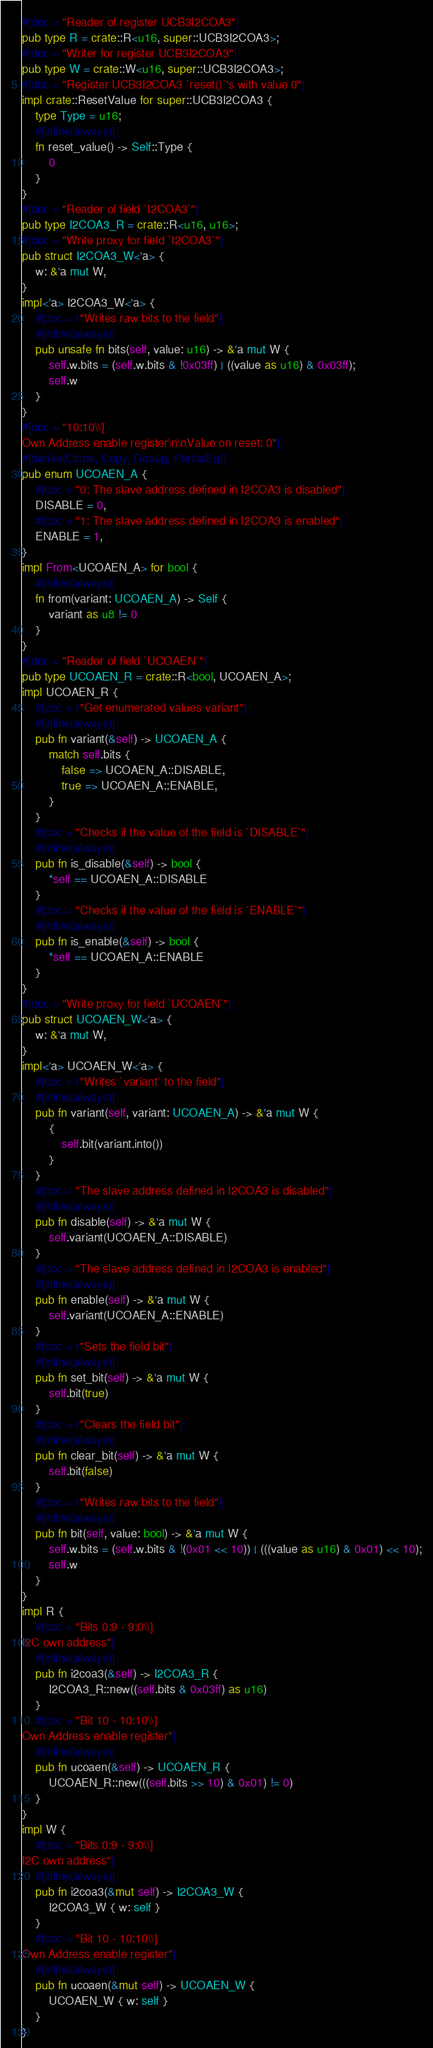Convert code to text. <code><loc_0><loc_0><loc_500><loc_500><_Rust_>#[doc = "Reader of register UCB3I2COA3"]
pub type R = crate::R<u16, super::UCB3I2COA3>;
#[doc = "Writer for register UCB3I2COA3"]
pub type W = crate::W<u16, super::UCB3I2COA3>;
#[doc = "Register UCB3I2COA3 `reset()`'s with value 0"]
impl crate::ResetValue for super::UCB3I2COA3 {
    type Type = u16;
    #[inline(always)]
    fn reset_value() -> Self::Type {
        0
    }
}
#[doc = "Reader of field `I2COA3`"]
pub type I2COA3_R = crate::R<u16, u16>;
#[doc = "Write proxy for field `I2COA3`"]
pub struct I2COA3_W<'a> {
    w: &'a mut W,
}
impl<'a> I2COA3_W<'a> {
    #[doc = r"Writes raw bits to the field"]
    #[inline(always)]
    pub unsafe fn bits(self, value: u16) -> &'a mut W {
        self.w.bits = (self.w.bits & !0x03ff) | ((value as u16) & 0x03ff);
        self.w
    }
}
#[doc = "10:10\\]
Own Address enable register\n\nValue on reset: 0"]
#[derive(Clone, Copy, Debug, PartialEq)]
pub enum UCOAEN_A {
    #[doc = "0: The slave address defined in I2COA3 is disabled"]
    DISABLE = 0,
    #[doc = "1: The slave address defined in I2COA3 is enabled"]
    ENABLE = 1,
}
impl From<UCOAEN_A> for bool {
    #[inline(always)]
    fn from(variant: UCOAEN_A) -> Self {
        variant as u8 != 0
    }
}
#[doc = "Reader of field `UCOAEN`"]
pub type UCOAEN_R = crate::R<bool, UCOAEN_A>;
impl UCOAEN_R {
    #[doc = r"Get enumerated values variant"]
    #[inline(always)]
    pub fn variant(&self) -> UCOAEN_A {
        match self.bits {
            false => UCOAEN_A::DISABLE,
            true => UCOAEN_A::ENABLE,
        }
    }
    #[doc = "Checks if the value of the field is `DISABLE`"]
    #[inline(always)]
    pub fn is_disable(&self) -> bool {
        *self == UCOAEN_A::DISABLE
    }
    #[doc = "Checks if the value of the field is `ENABLE`"]
    #[inline(always)]
    pub fn is_enable(&self) -> bool {
        *self == UCOAEN_A::ENABLE
    }
}
#[doc = "Write proxy for field `UCOAEN`"]
pub struct UCOAEN_W<'a> {
    w: &'a mut W,
}
impl<'a> UCOAEN_W<'a> {
    #[doc = r"Writes `variant` to the field"]
    #[inline(always)]
    pub fn variant(self, variant: UCOAEN_A) -> &'a mut W {
        {
            self.bit(variant.into())
        }
    }
    #[doc = "The slave address defined in I2COA3 is disabled"]
    #[inline(always)]
    pub fn disable(self) -> &'a mut W {
        self.variant(UCOAEN_A::DISABLE)
    }
    #[doc = "The slave address defined in I2COA3 is enabled"]
    #[inline(always)]
    pub fn enable(self) -> &'a mut W {
        self.variant(UCOAEN_A::ENABLE)
    }
    #[doc = r"Sets the field bit"]
    #[inline(always)]
    pub fn set_bit(self) -> &'a mut W {
        self.bit(true)
    }
    #[doc = r"Clears the field bit"]
    #[inline(always)]
    pub fn clear_bit(self) -> &'a mut W {
        self.bit(false)
    }
    #[doc = r"Writes raw bits to the field"]
    #[inline(always)]
    pub fn bit(self, value: bool) -> &'a mut W {
        self.w.bits = (self.w.bits & !(0x01 << 10)) | (((value as u16) & 0x01) << 10);
        self.w
    }
}
impl R {
    #[doc = "Bits 0:9 - 9:0\\]
I2C own address"]
    #[inline(always)]
    pub fn i2coa3(&self) -> I2COA3_R {
        I2COA3_R::new((self.bits & 0x03ff) as u16)
    }
    #[doc = "Bit 10 - 10:10\\]
Own Address enable register"]
    #[inline(always)]
    pub fn ucoaen(&self) -> UCOAEN_R {
        UCOAEN_R::new(((self.bits >> 10) & 0x01) != 0)
    }
}
impl W {
    #[doc = "Bits 0:9 - 9:0\\]
I2C own address"]
    #[inline(always)]
    pub fn i2coa3(&mut self) -> I2COA3_W {
        I2COA3_W { w: self }
    }
    #[doc = "Bit 10 - 10:10\\]
Own Address enable register"]
    #[inline(always)]
    pub fn ucoaen(&mut self) -> UCOAEN_W {
        UCOAEN_W { w: self }
    }
}
</code> 